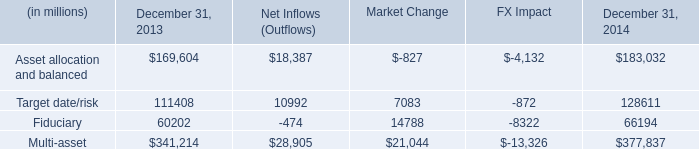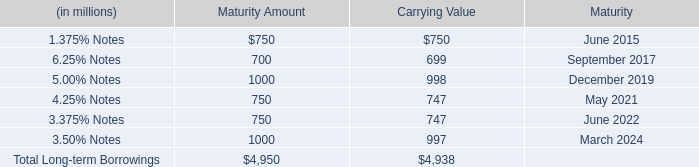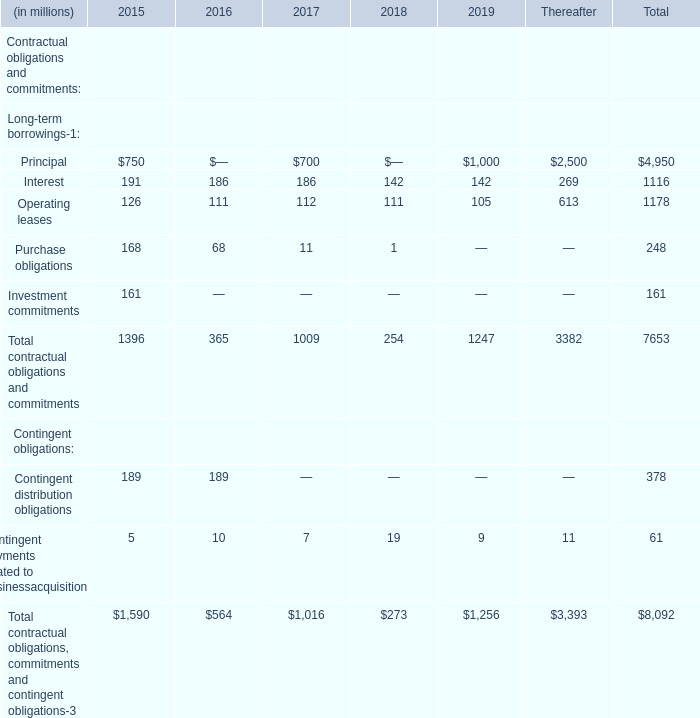What is the growing rate of interest in the year with the most principle? 
Computations: ((186 - 142) / 142)
Answer: 0.30986. 